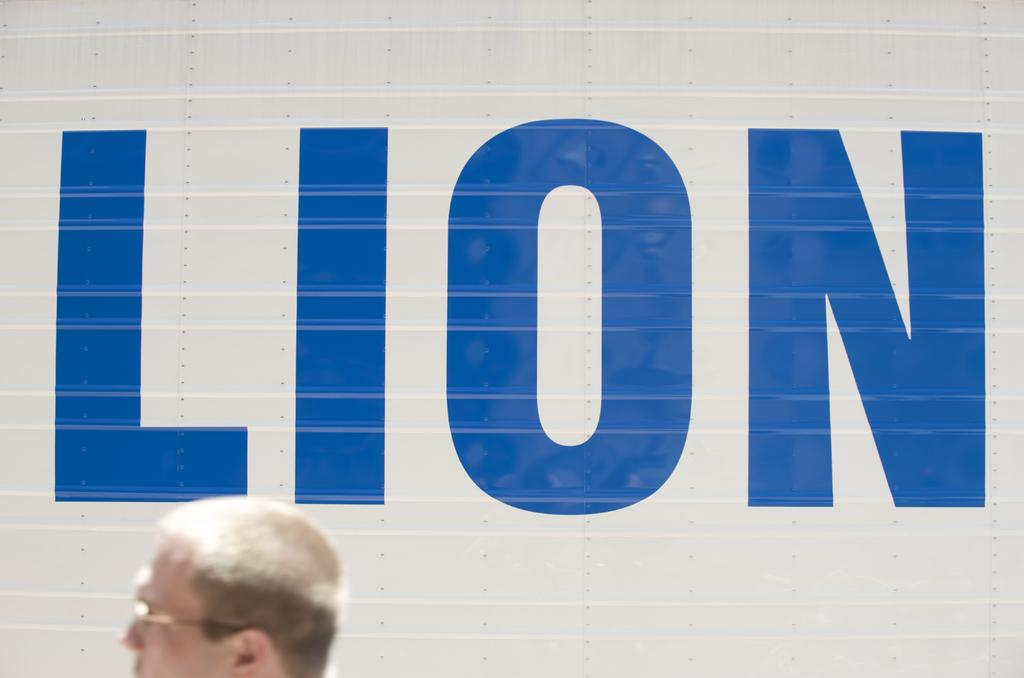What is the main subject of the image? The main subject of the image is a person's head. Can you describe anything else in the image besides the person's head? Yes, there is text on a surface in the background of the image. What type of cloud can be seen in the image? There is no cloud present in the image; it only features a person's head and text on a surface in the background. 